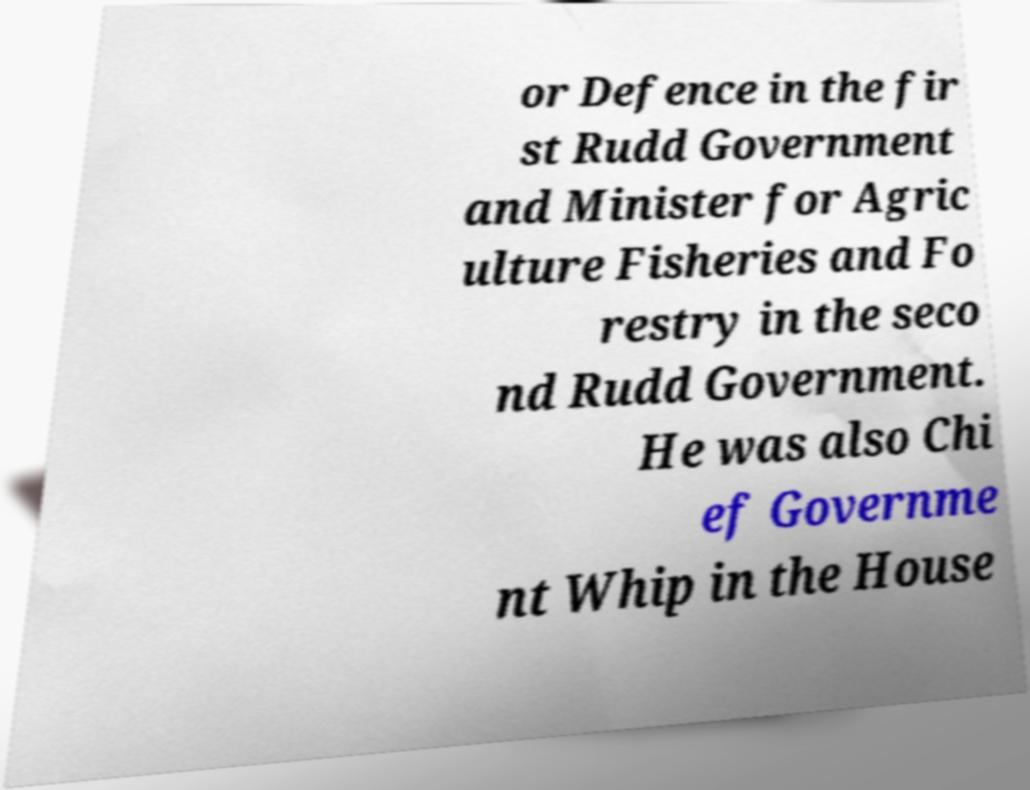Could you assist in decoding the text presented in this image and type it out clearly? or Defence in the fir st Rudd Government and Minister for Agric ulture Fisheries and Fo restry in the seco nd Rudd Government. He was also Chi ef Governme nt Whip in the House 